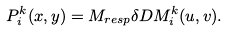<formula> <loc_0><loc_0><loc_500><loc_500>P _ { i } ^ { k } ( x , y ) = M _ { r e s p } \delta D M _ { i } ^ { k } ( u , v ) .</formula> 